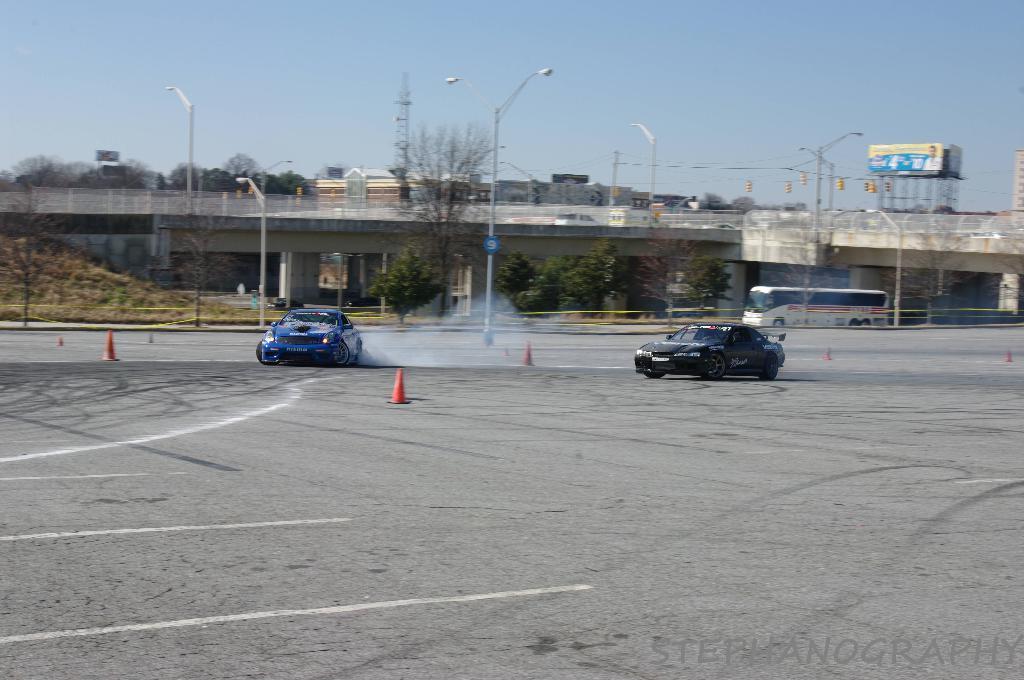Describe this image in one or two sentences. There are vehicles on the road on which, there are small poles and white color lines. In the background, there are lights attached to the poles, there is a vehicle on the road, a bridge, there are trees, buildings and there is blue sky. 